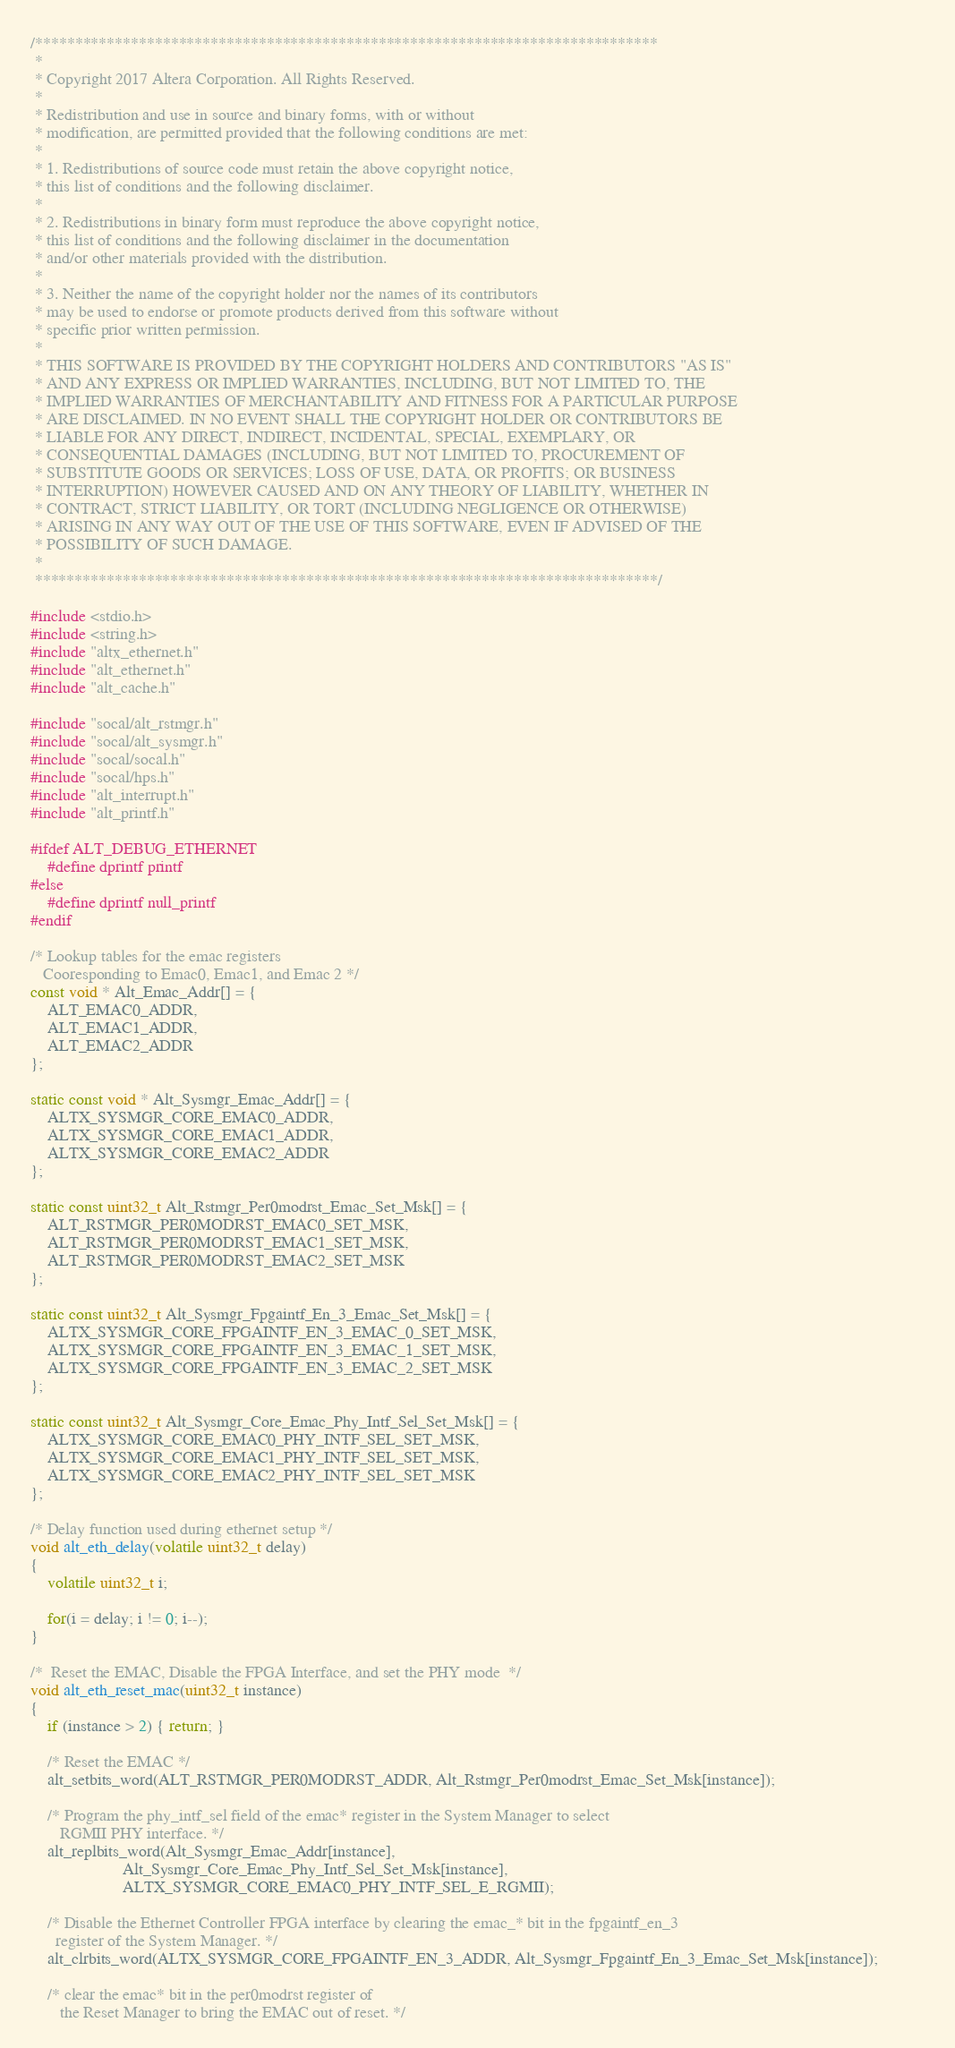<code> <loc_0><loc_0><loc_500><loc_500><_C_>/******************************************************************************
 *
 * Copyright 2017 Altera Corporation. All Rights Reserved.
 *
 * Redistribution and use in source and binary forms, with or without
 * modification, are permitted provided that the following conditions are met:
 *
 * 1. Redistributions of source code must retain the above copyright notice,
 * this list of conditions and the following disclaimer.
 *
 * 2. Redistributions in binary form must reproduce the above copyright notice,
 * this list of conditions and the following disclaimer in the documentation
 * and/or other materials provided with the distribution.
 *
 * 3. Neither the name of the copyright holder nor the names of its contributors
 * may be used to endorse or promote products derived from this software without
 * specific prior written permission.
 *
 * THIS SOFTWARE IS PROVIDED BY THE COPYRIGHT HOLDERS AND CONTRIBUTORS "AS IS"
 * AND ANY EXPRESS OR IMPLIED WARRANTIES, INCLUDING, BUT NOT LIMITED TO, THE
 * IMPLIED WARRANTIES OF MERCHANTABILITY AND FITNESS FOR A PARTICULAR PURPOSE
 * ARE DISCLAIMED. IN NO EVENT SHALL THE COPYRIGHT HOLDER OR CONTRIBUTORS BE
 * LIABLE FOR ANY DIRECT, INDIRECT, INCIDENTAL, SPECIAL, EXEMPLARY, OR
 * CONSEQUENTIAL DAMAGES (INCLUDING, BUT NOT LIMITED TO, PROCUREMENT OF
 * SUBSTITUTE GOODS OR SERVICES; LOSS OF USE, DATA, OR PROFITS; OR BUSINESS
 * INTERRUPTION) HOWEVER CAUSED AND ON ANY THEORY OF LIABILITY, WHETHER IN
 * CONTRACT, STRICT LIABILITY, OR TORT (INCLUDING NEGLIGENCE OR OTHERWISE)
 * ARISING IN ANY WAY OUT OF THE USE OF THIS SOFTWARE, EVEN IF ADVISED OF THE
 * POSSIBILITY OF SUCH DAMAGE.
 *
 ******************************************************************************/
 
#include <stdio.h>
#include <string.h>
#include "altx_ethernet.h"
#include "alt_ethernet.h"
#include "alt_cache.h"

#include "socal/alt_rstmgr.h"
#include "socal/alt_sysmgr.h"
#include "socal/socal.h"
#include "socal/hps.h"
#include "alt_interrupt.h"
#include "alt_printf.h"

#ifdef ALT_DEBUG_ETHERNET
    #define dprintf printf
#else
    #define dprintf null_printf
#endif
 
/* Lookup tables for the emac registers 
   Cooresponding to Emac0, Emac1, and Emac 2 */
const void * Alt_Emac_Addr[] = {
    ALT_EMAC0_ADDR,
    ALT_EMAC1_ADDR,
    ALT_EMAC2_ADDR
};

static const void * Alt_Sysmgr_Emac_Addr[] = {
    ALTX_SYSMGR_CORE_EMAC0_ADDR,
    ALTX_SYSMGR_CORE_EMAC1_ADDR,
    ALTX_SYSMGR_CORE_EMAC2_ADDR
};

static const uint32_t Alt_Rstmgr_Per0modrst_Emac_Set_Msk[] = {
    ALT_RSTMGR_PER0MODRST_EMAC0_SET_MSK,
    ALT_RSTMGR_PER0MODRST_EMAC1_SET_MSK,
    ALT_RSTMGR_PER0MODRST_EMAC2_SET_MSK
};

static const uint32_t Alt_Sysmgr_Fpgaintf_En_3_Emac_Set_Msk[] = {
    ALTX_SYSMGR_CORE_FPGAINTF_EN_3_EMAC_0_SET_MSK,
    ALTX_SYSMGR_CORE_FPGAINTF_EN_3_EMAC_1_SET_MSK,
    ALTX_SYSMGR_CORE_FPGAINTF_EN_3_EMAC_2_SET_MSK
};

static const uint32_t Alt_Sysmgr_Core_Emac_Phy_Intf_Sel_Set_Msk[] = {
    ALTX_SYSMGR_CORE_EMAC0_PHY_INTF_SEL_SET_MSK,
    ALTX_SYSMGR_CORE_EMAC1_PHY_INTF_SEL_SET_MSK,
    ALTX_SYSMGR_CORE_EMAC2_PHY_INTF_SEL_SET_MSK
};

/* Delay function used during ethernet setup */
void alt_eth_delay(volatile uint32_t delay)
{
    volatile uint32_t i; 
    
    for(i = delay; i != 0; i--);
}

/*  Reset the EMAC, Disable the FPGA Interface, and set the PHY mode  */
void alt_eth_reset_mac(uint32_t instance)
{
    if (instance > 2) { return; }
     
    /* Reset the EMAC */
    alt_setbits_word(ALT_RSTMGR_PER0MODRST_ADDR, Alt_Rstmgr_Per0modrst_Emac_Set_Msk[instance]);
    
    /* Program the phy_intf_sel field of the emac* register in the System Manager to select
       RGMII PHY interface. */
    alt_replbits_word(Alt_Sysmgr_Emac_Addr[instance],
                      Alt_Sysmgr_Core_Emac_Phy_Intf_Sel_Set_Msk[instance],  
                      ALTX_SYSMGR_CORE_EMAC0_PHY_INTF_SEL_E_RGMII);
                    
    /* Disable the Ethernet Controller FPGA interface by clearing the emac_* bit in the fpgaintf_en_3
      register of the System Manager. */
    alt_clrbits_word(ALTX_SYSMGR_CORE_FPGAINTF_EN_3_ADDR, Alt_Sysmgr_Fpgaintf_En_3_Emac_Set_Msk[instance]);           
                    
    /* clear the emac* bit in the per0modrst register of
       the Reset Manager to bring the EMAC out of reset. */</code> 